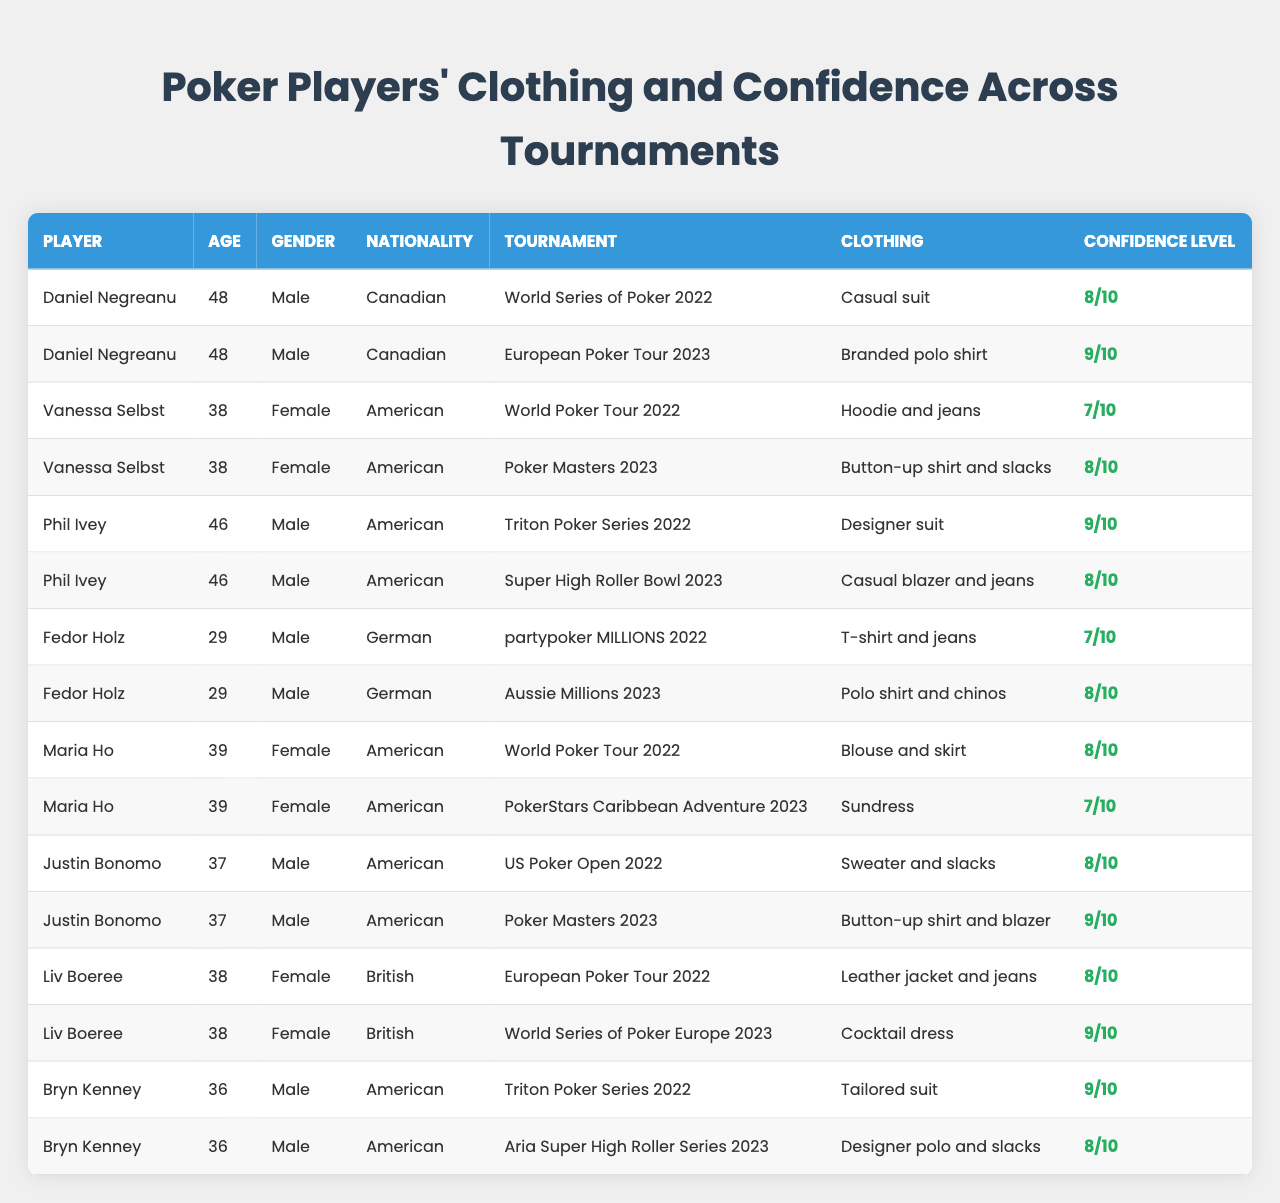What clothing did Daniel Negreanu wear at the European Poker Tour 2023? The table lists the tournaments alongside player names and their respective clothing choices. For Daniel Negreanu at the European Poker Tour 2023, the clothing mentioned is "Branded polo shirt."
Answer: Branded polo shirt What is the confidence level of Vanessa Selbst during the World Poker Tour 2022? By checking the specific row for Vanessa Selbst and the World Poker Tour 2022, the confidence level is indicated as 7 out of 10.
Answer: 7 Which player showed the highest confidence level across all tournaments? To determine this, we can compare the highest confidence levels listed for each player. Phil Ivey, Bryn Kenney, and Justin Bonomo all have a confidence level of 9, which is the highest among all.
Answer: Phil Ivey, Bryn Kenney, Justin Bonomo How many players have a confidence level of 8 or higher in any tournament? We review the confidence levels for each player in the tournaments. Players with confidence levels of 8 or higher are Daniel Negreanu, Phil Ivey, Vanessa Selbst, Maria Ho, Justin Bonomo, Liv Boeree, and Bryn Kenney, which totals to 7 players.
Answer: 7 Did any female player have a higher confidence level than a male player during the same tournament? By analyzing the confidence levels, Liv Boeree scored 9 in the World Series of Poker Europe 2023, which is higher than all male players in their respective tournaments, confirming that a female player had greater confidence.
Answer: Yes What is the average confidence level for all players at the Triton Poker Series 2022? Only Phil Ivey and Bryn Kenney participated in the Triton Poker Series 2022, with confidence levels of 9 and 9. Therefore, the average is calculated as (9 + 9) / 2 = 9.
Answer: 9 How did the confidence level of Fedor Holz change from partypoker MILLIONS 2022 to Aussie Millions 2023? Fedor Holz's confidence level was 7 at partypoker MILLIONS 2022 and increased to 8 at Aussie Millions 2023. The change in level is an increase of 1 point.
Answer: Increased by 1 Which clothing choice was associated with the lowest confidence level among players? Reviewing the table reveals that Fedor Holz wore a "T-shirt and jeans" at partypoker MILLIONS 2022, with a confidence level of 7, which is the lowest.
Answer: T-shirt and jeans What is the sum of confidence levels for all tournaments for each female player? For Vanessa Selbst: 7 + 8 = 15; Maria Ho: 8 + 7 = 15; Liv Boeree: 8 + 9 = 17. Therefore, the sum of confidence levels for female players is (15 + 15 + 17) = 47.
Answer: 47 Did any player wear a cocktail dress or sundress? The data indicates Liv Boeree wore a cocktail dress and Maria Ho wore a sundress in their respective tournaments, confirming that both clothing types were worn by players.
Answer: Yes 